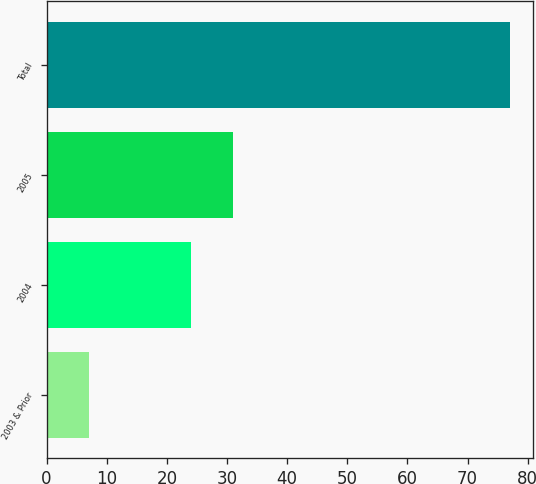Convert chart to OTSL. <chart><loc_0><loc_0><loc_500><loc_500><bar_chart><fcel>2003 & Prior<fcel>2004<fcel>2005<fcel>Total<nl><fcel>7<fcel>24<fcel>31<fcel>77<nl></chart> 